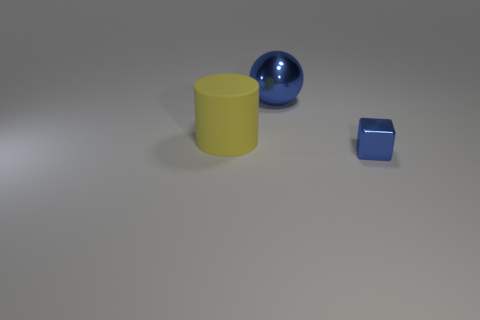Subtract all gray balls. Subtract all brown blocks. How many balls are left? 1 Add 1 large blue balls. How many objects exist? 4 Subtract all cubes. How many objects are left? 2 Add 1 spheres. How many spheres are left? 2 Add 3 small cyan balls. How many small cyan balls exist? 3 Subtract 1 blue cubes. How many objects are left? 2 Subtract all large yellow objects. Subtract all yellow cylinders. How many objects are left? 1 